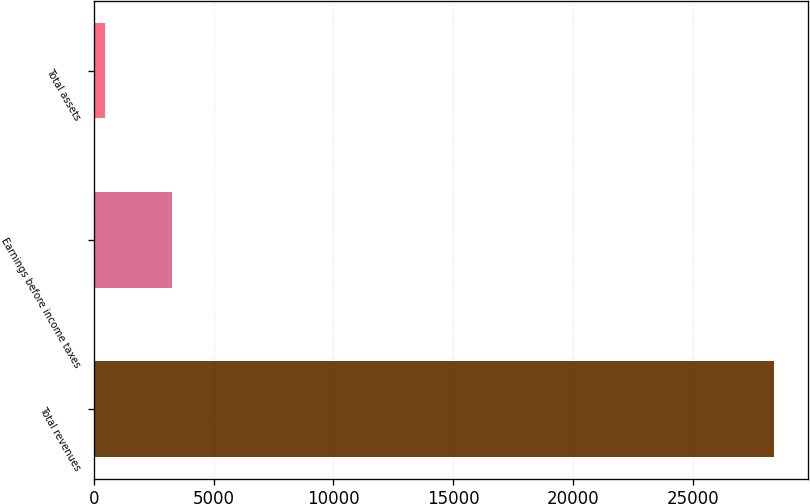Convert chart to OTSL. <chart><loc_0><loc_0><loc_500><loc_500><bar_chart><fcel>Total revenues<fcel>Earnings before income taxes<fcel>Total assets<nl><fcel>28375<fcel>3276.7<fcel>488<nl></chart> 